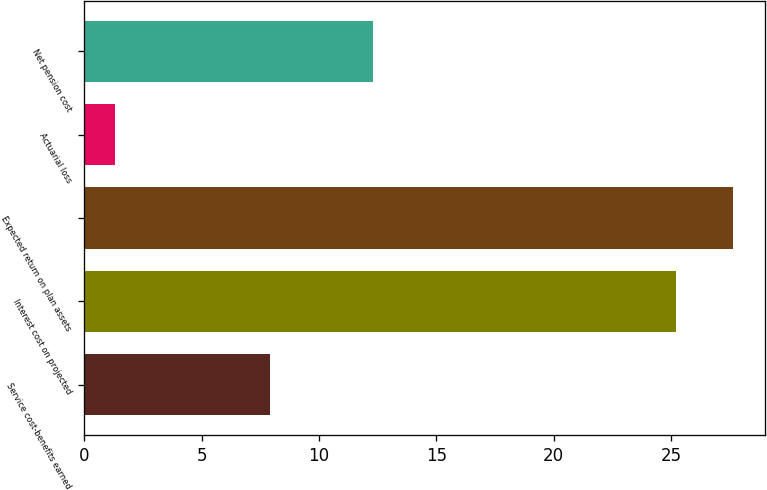<chart> <loc_0><loc_0><loc_500><loc_500><bar_chart><fcel>Service cost-benefits earned<fcel>Interest cost on projected<fcel>Expected return on plan assets<fcel>Actuarial loss<fcel>Net pension cost<nl><fcel>7.9<fcel>25.2<fcel>27.63<fcel>1.3<fcel>12.3<nl></chart> 